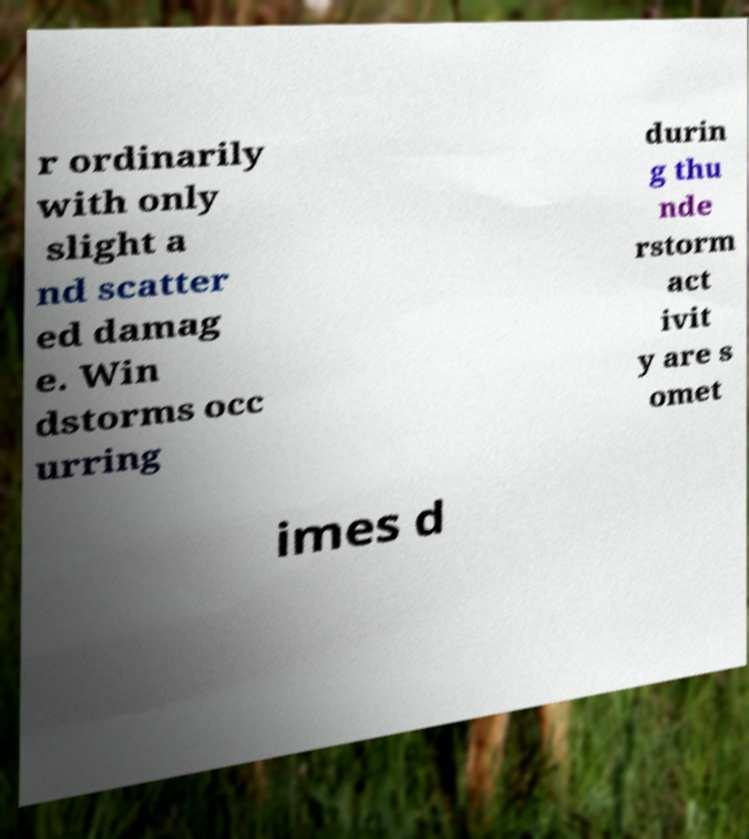I need the written content from this picture converted into text. Can you do that? r ordinarily with only slight a nd scatter ed damag e. Win dstorms occ urring durin g thu nde rstorm act ivit y are s omet imes d 